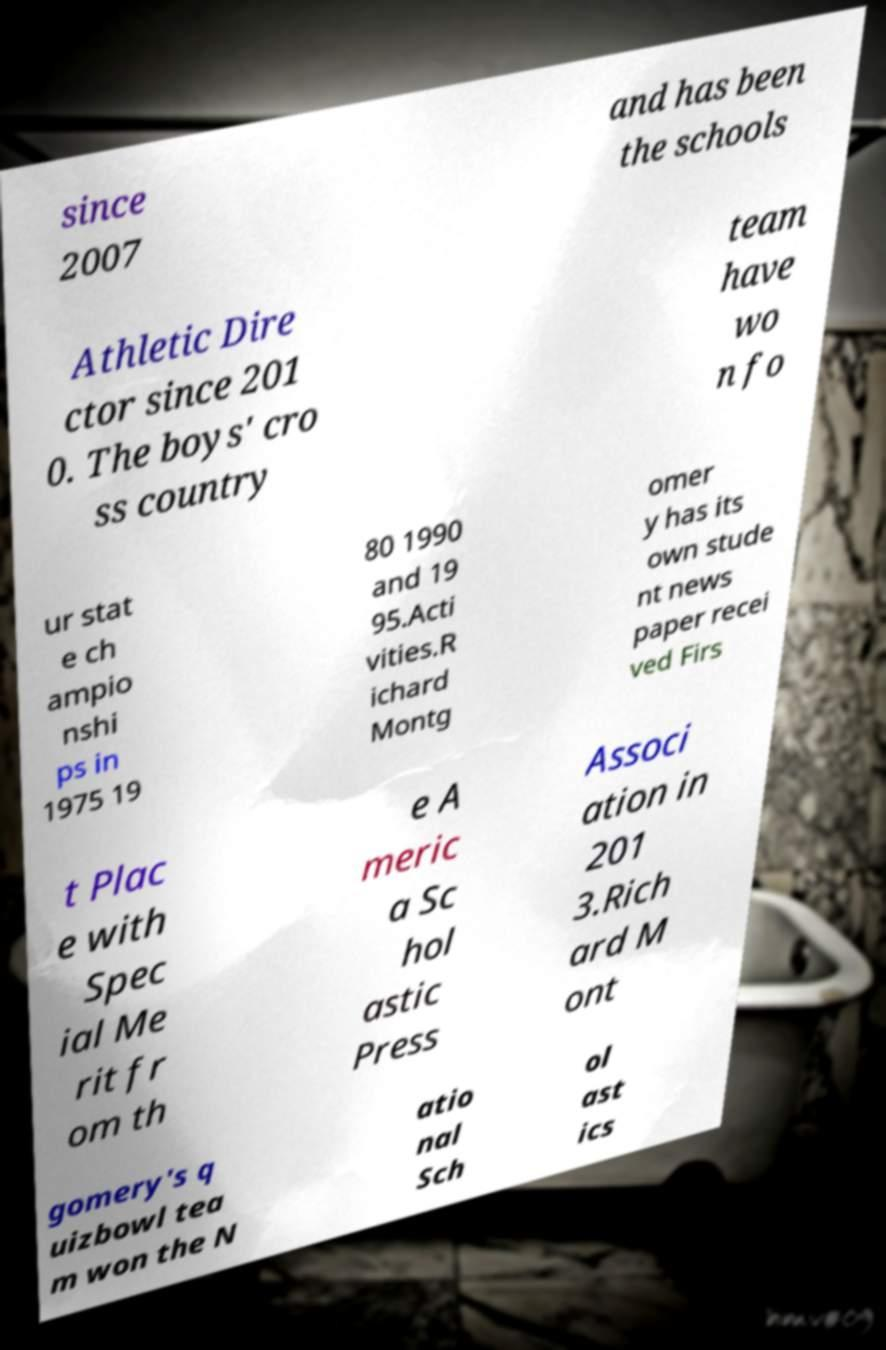Please read and relay the text visible in this image. What does it say? since 2007 and has been the schools Athletic Dire ctor since 201 0. The boys' cro ss country team have wo n fo ur stat e ch ampio nshi ps in 1975 19 80 1990 and 19 95.Acti vities.R ichard Montg omer y has its own stude nt news paper recei ved Firs t Plac e with Spec ial Me rit fr om th e A meric a Sc hol astic Press Associ ation in 201 3.Rich ard M ont gomery's q uizbowl tea m won the N atio nal Sch ol ast ics 